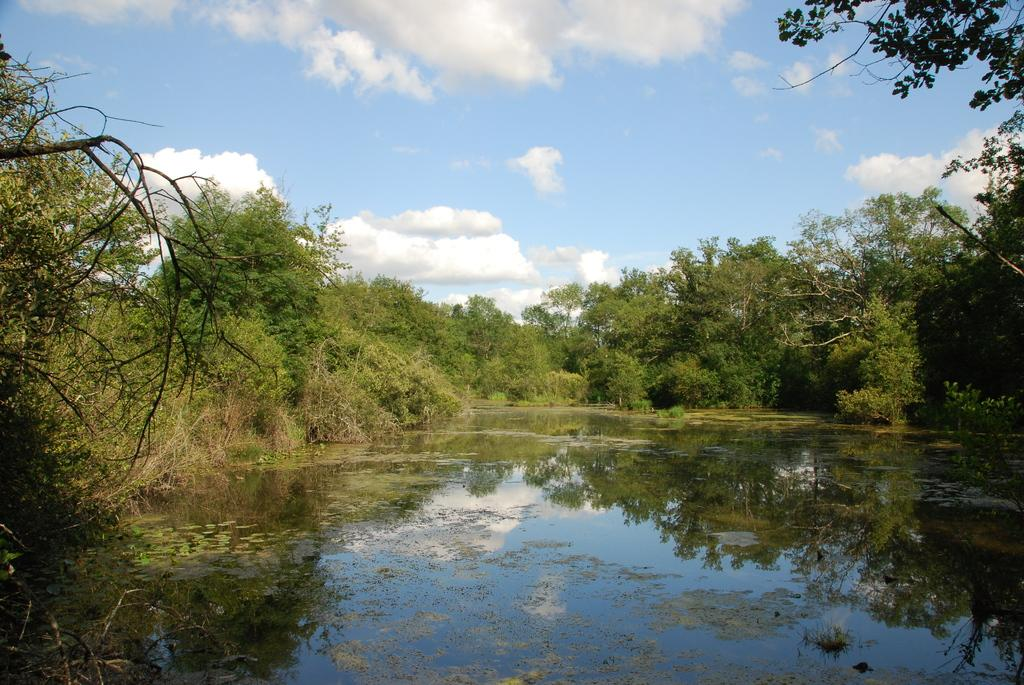What is at the bottom of the image? There is water at the bottom of the image. What can be seen in the background of the image? There are trees in the background of the image. What is visible at the top of the image? The sky is visible at the top of the image. What can be observed in the sky? Clouds are present in the sky. How many cherries are hanging from the trees in the image? There are no cherries present in the image; it features trees in the background. Can you describe the grass in the image? There is no grass visible in the image; it only shows water, trees, and the sky. 